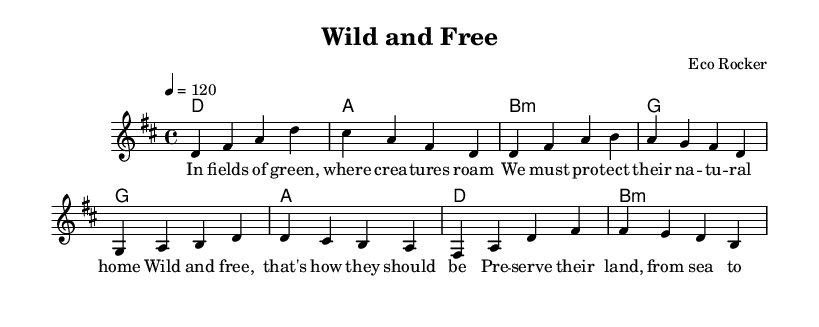What is the key signature of this music? The key signature is indicated at the beginning of the staff and is D major, which has two sharps (F# and C#).
Answer: D major What is the time signature of this piece? The time signature is found at the start of the piece and is 4/4, which indicates four beats per measure.
Answer: 4/4 What is the tempo marking for the piece? The tempo information is indicated with the marking "4 = 120," meaning there are 120 beats per minute.
Answer: 120 How many measures are in the verse melody? The verse melody consists of four measures, which can be counted from the notation provided.
Answer: 4 What chords are used in the chorus section? The chords listed above the staff in the harmonies section for the chorus include A, D, and F#.
Answer: A, D, F# Which lyric line specifies the need for wildlife preservation? The lyric line "Preserve their land, from sea to sea" clearly expresses the intention of protecting wildlife habitats.
Answer: Preserve their land, from sea to sea What type of musical piece is represented here? The structure, chords, and lyrics reflect characteristics of a rock anthem aimed at promoting environmental and wildlife conservation.
Answer: Rock anthem 